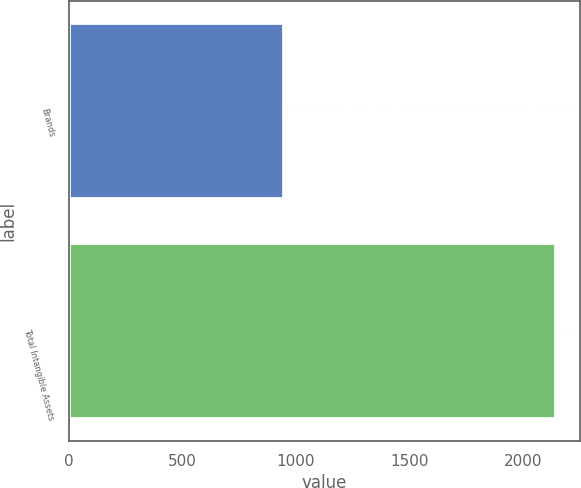<chart> <loc_0><loc_0><loc_500><loc_500><bar_chart><fcel>Brands<fcel>Total Intangible Assets<nl><fcel>946<fcel>2143<nl></chart> 